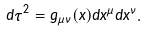<formula> <loc_0><loc_0><loc_500><loc_500>d \tau ^ { 2 } = g _ { \mu \nu } ( x ) d x ^ { \mu } d x ^ { \nu } .</formula> 